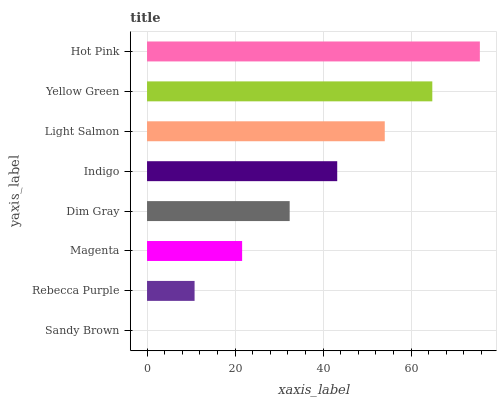Is Sandy Brown the minimum?
Answer yes or no. Yes. Is Hot Pink the maximum?
Answer yes or no. Yes. Is Rebecca Purple the minimum?
Answer yes or no. No. Is Rebecca Purple the maximum?
Answer yes or no. No. Is Rebecca Purple greater than Sandy Brown?
Answer yes or no. Yes. Is Sandy Brown less than Rebecca Purple?
Answer yes or no. Yes. Is Sandy Brown greater than Rebecca Purple?
Answer yes or no. No. Is Rebecca Purple less than Sandy Brown?
Answer yes or no. No. Is Indigo the high median?
Answer yes or no. Yes. Is Dim Gray the low median?
Answer yes or no. Yes. Is Light Salmon the high median?
Answer yes or no. No. Is Rebecca Purple the low median?
Answer yes or no. No. 